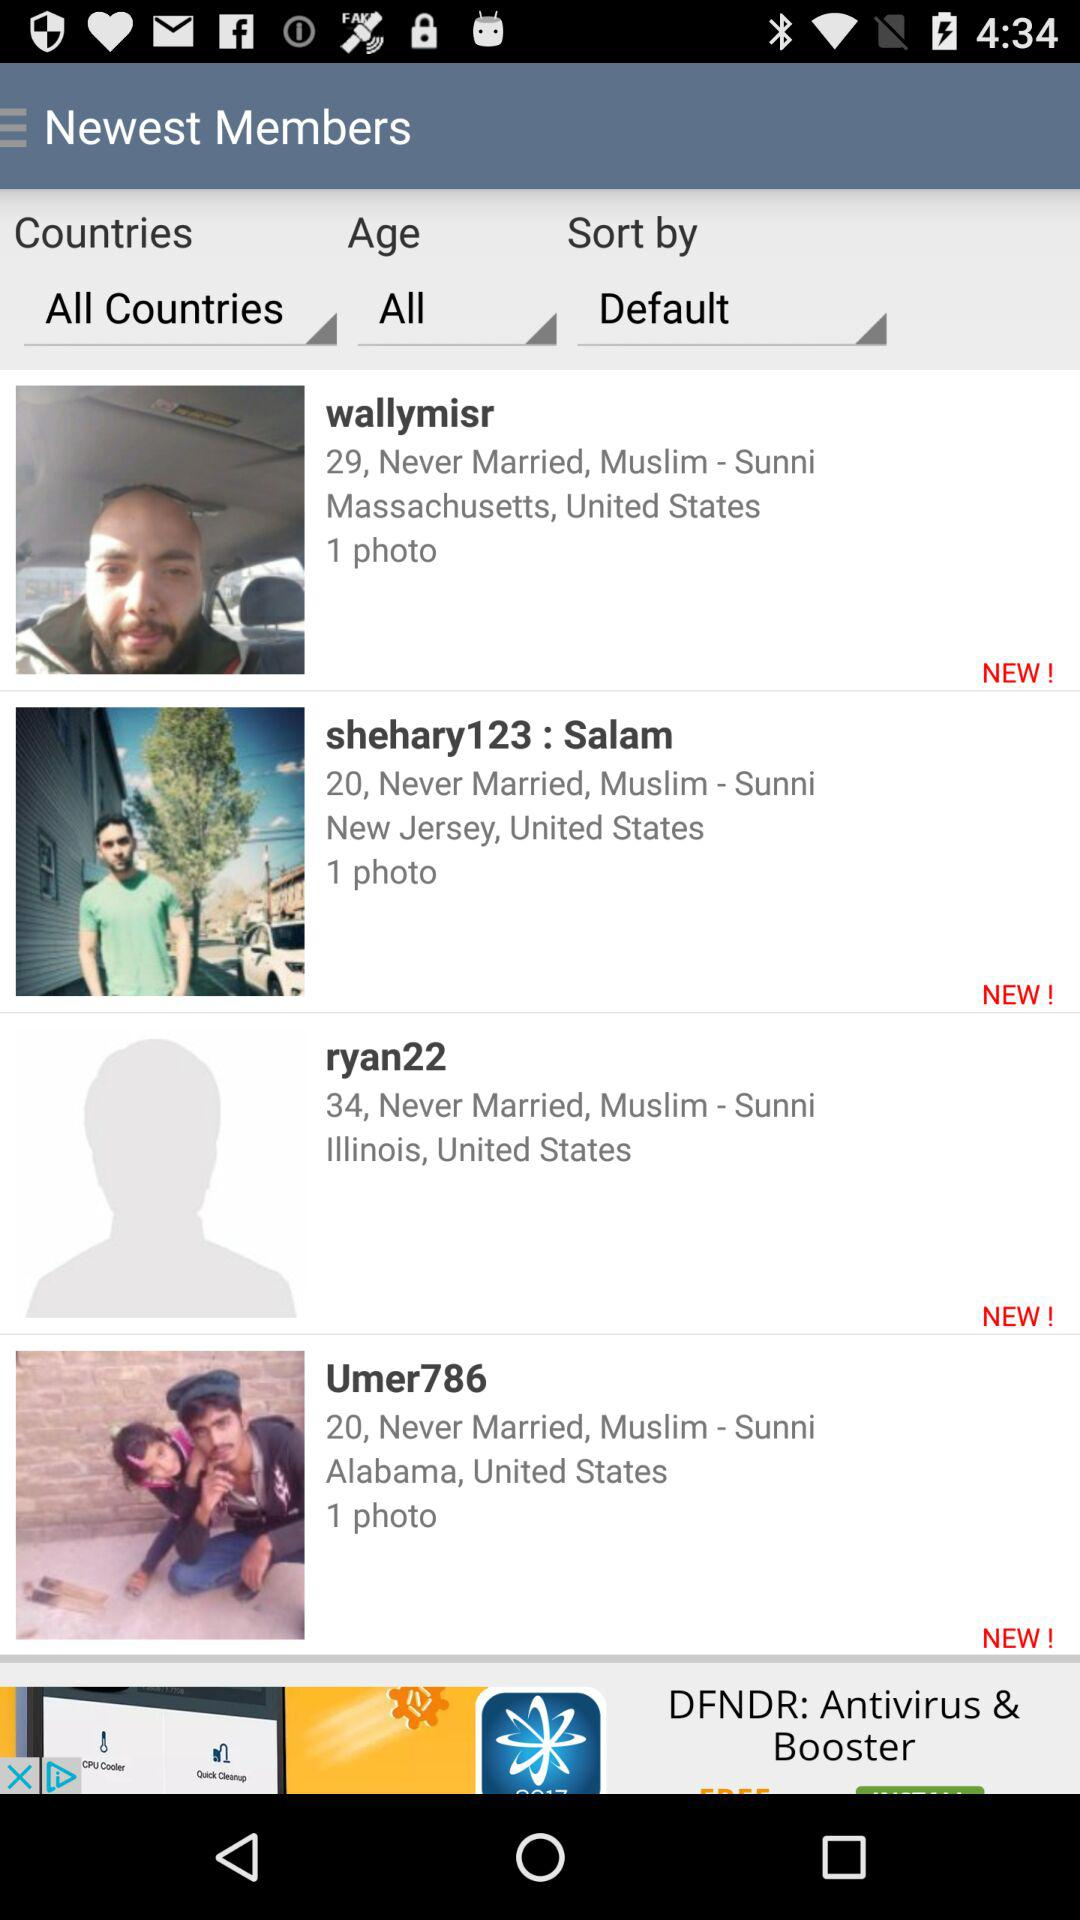What is the marital status of "Umer786"? The marital status is "Never Married". 